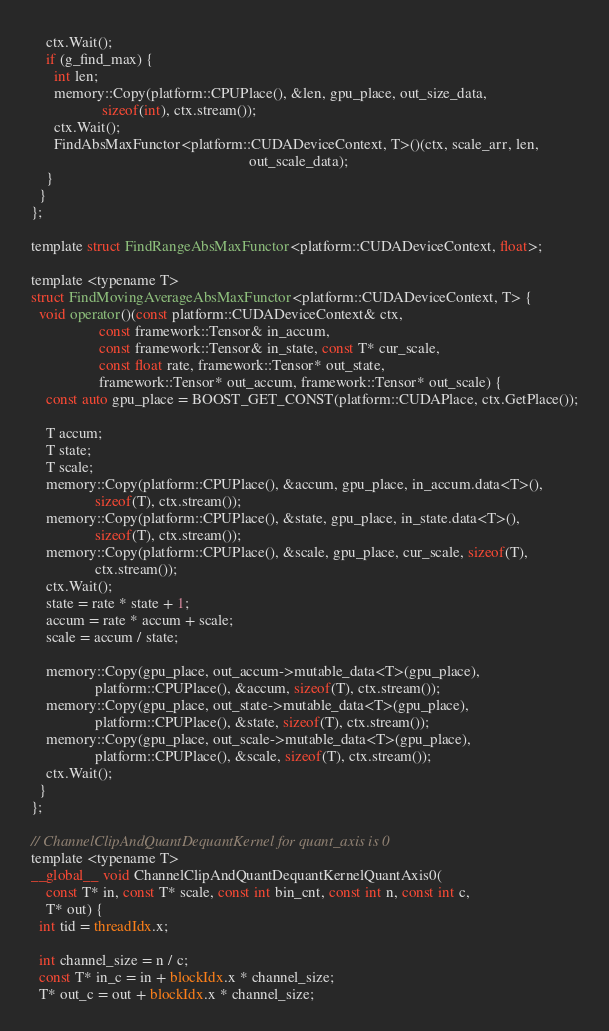<code> <loc_0><loc_0><loc_500><loc_500><_Cuda_>    ctx.Wait();
    if (g_find_max) {
      int len;
      memory::Copy(platform::CPUPlace(), &len, gpu_place, out_size_data,
                   sizeof(int), ctx.stream());
      ctx.Wait();
      FindAbsMaxFunctor<platform::CUDADeviceContext, T>()(ctx, scale_arr, len,
                                                          out_scale_data);
    }
  }
};

template struct FindRangeAbsMaxFunctor<platform::CUDADeviceContext, float>;

template <typename T>
struct FindMovingAverageAbsMaxFunctor<platform::CUDADeviceContext, T> {
  void operator()(const platform::CUDADeviceContext& ctx,
                  const framework::Tensor& in_accum,
                  const framework::Tensor& in_state, const T* cur_scale,
                  const float rate, framework::Tensor* out_state,
                  framework::Tensor* out_accum, framework::Tensor* out_scale) {
    const auto gpu_place = BOOST_GET_CONST(platform::CUDAPlace, ctx.GetPlace());

    T accum;
    T state;
    T scale;
    memory::Copy(platform::CPUPlace(), &accum, gpu_place, in_accum.data<T>(),
                 sizeof(T), ctx.stream());
    memory::Copy(platform::CPUPlace(), &state, gpu_place, in_state.data<T>(),
                 sizeof(T), ctx.stream());
    memory::Copy(platform::CPUPlace(), &scale, gpu_place, cur_scale, sizeof(T),
                 ctx.stream());
    ctx.Wait();
    state = rate * state + 1;
    accum = rate * accum + scale;
    scale = accum / state;

    memory::Copy(gpu_place, out_accum->mutable_data<T>(gpu_place),
                 platform::CPUPlace(), &accum, sizeof(T), ctx.stream());
    memory::Copy(gpu_place, out_state->mutable_data<T>(gpu_place),
                 platform::CPUPlace(), &state, sizeof(T), ctx.stream());
    memory::Copy(gpu_place, out_scale->mutable_data<T>(gpu_place),
                 platform::CPUPlace(), &scale, sizeof(T), ctx.stream());
    ctx.Wait();
  }
};

// ChannelClipAndQuantDequantKernel for quant_axis is 0
template <typename T>
__global__ void ChannelClipAndQuantDequantKernelQuantAxis0(
    const T* in, const T* scale, const int bin_cnt, const int n, const int c,
    T* out) {
  int tid = threadIdx.x;

  int channel_size = n / c;
  const T* in_c = in + blockIdx.x * channel_size;
  T* out_c = out + blockIdx.x * channel_size;
</code> 